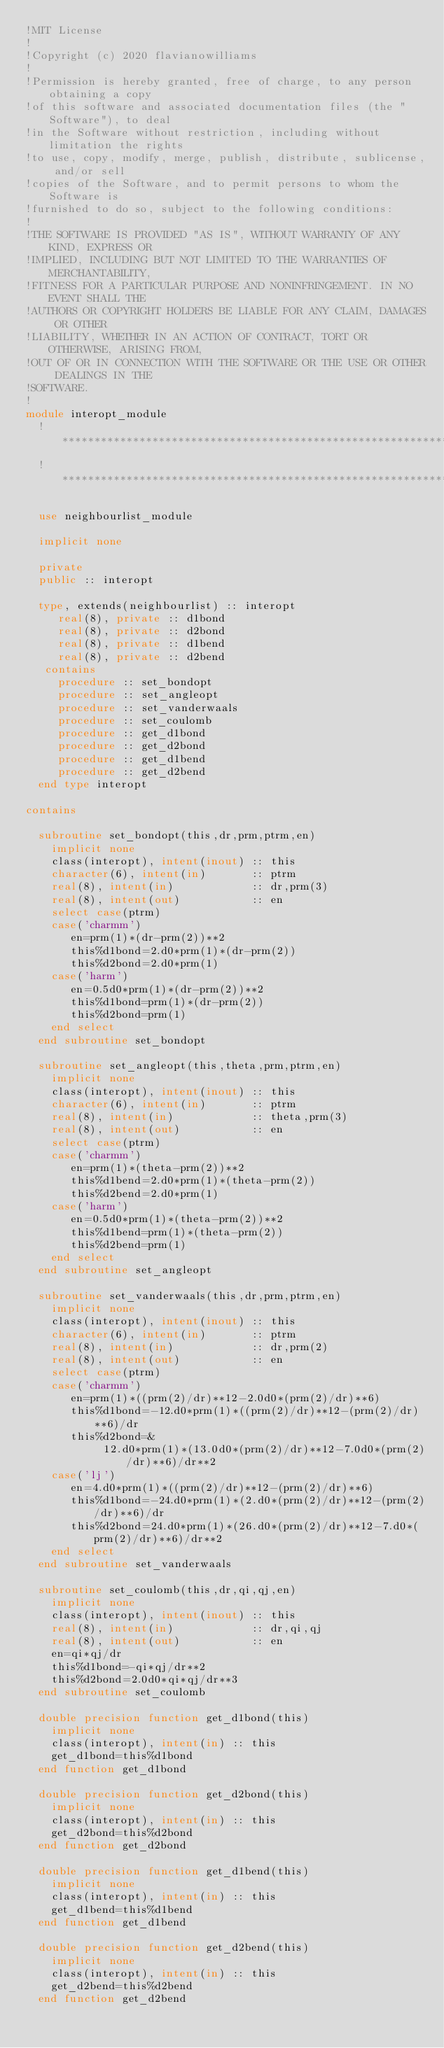<code> <loc_0><loc_0><loc_500><loc_500><_FORTRAN_>!MIT License
!
!Copyright (c) 2020 flavianowilliams
!
!Permission is hereby granted, free of charge, to any person obtaining a copy
!of this software and associated documentation files (the "Software"), to deal
!in the Software without restriction, including without limitation the rights
!to use, copy, modify, merge, publish, distribute, sublicense, and/or sell
!copies of the Software, and to permit persons to whom the Software is
!furnished to do so, subject to the following conditions:
!
!THE SOFTWARE IS PROVIDED "AS IS", WITHOUT WARRANTY OF ANY KIND, EXPRESS OR
!IMPLIED, INCLUDING BUT NOT LIMITED TO THE WARRANTIES OF MERCHANTABILITY,
!FITNESS FOR A PARTICULAR PURPOSE AND NONINFRINGEMENT. IN NO EVENT SHALL THE
!AUTHORS OR COPYRIGHT HOLDERS BE LIABLE FOR ANY CLAIM, DAMAGES OR OTHER
!LIABILITY, WHETHER IN AN ACTION OF CONTRACT, TORT OR OTHERWISE, ARISING FROM,
!OUT OF OR IN CONNECTION WITH THE SOFTWARE OR THE USE OR OTHER DEALINGS IN THE
!SOFTWARE.
!
module interopt_module
  !*******************************************************************************************
  !*******************************************************************************************

  use neighbourlist_module

  implicit none

  private
  public :: interopt

  type, extends(neighbourlist) :: interopt
     real(8), private :: d1bond
     real(8), private :: d2bond
     real(8), private :: d1bend
     real(8), private :: d2bend
   contains
     procedure :: set_bondopt
     procedure :: set_angleopt
     procedure :: set_vanderwaals
     procedure :: set_coulomb
     procedure :: get_d1bond
     procedure :: get_d2bond
     procedure :: get_d1bend
     procedure :: get_d2bend
  end type interopt

contains

  subroutine set_bondopt(this,dr,prm,ptrm,en)
    implicit none
    class(interopt), intent(inout) :: this
    character(6), intent(in)       :: ptrm
    real(8), intent(in)            :: dr,prm(3)
    real(8), intent(out)           :: en
    select case(ptrm)
    case('charmm')
       en=prm(1)*(dr-prm(2))**2
       this%d1bond=2.d0*prm(1)*(dr-prm(2))
       this%d2bond=2.d0*prm(1)
    case('harm')
       en=0.5d0*prm(1)*(dr-prm(2))**2
       this%d1bond=prm(1)*(dr-prm(2))
       this%d2bond=prm(1)
    end select
  end subroutine set_bondopt

  subroutine set_angleopt(this,theta,prm,ptrm,en)
    implicit none
    class(interopt), intent(inout) :: this
    character(6), intent(in)       :: ptrm
    real(8), intent(in)            :: theta,prm(3)
    real(8), intent(out)           :: en
    select case(ptrm)
    case('charmm')
       en=prm(1)*(theta-prm(2))**2
       this%d1bend=2.d0*prm(1)*(theta-prm(2))
       this%d2bend=2.d0*prm(1)
    case('harm')
       en=0.5d0*prm(1)*(theta-prm(2))**2
       this%d1bend=prm(1)*(theta-prm(2))
       this%d2bend=prm(1)
    end select
  end subroutine set_angleopt

  subroutine set_vanderwaals(this,dr,prm,ptrm,en)
    implicit none
    class(interopt), intent(inout) :: this
    character(6), intent(in)       :: ptrm
    real(8), intent(in)            :: dr,prm(2)
    real(8), intent(out)           :: en
    select case(ptrm)
    case('charmm')
       en=prm(1)*((prm(2)/dr)**12-2.0d0*(prm(2)/dr)**6)
       this%d1bond=-12.d0*prm(1)*((prm(2)/dr)**12-(prm(2)/dr)**6)/dr
       this%d2bond=&
            12.d0*prm(1)*(13.0d0*(prm(2)/dr)**12-7.0d0*(prm(2)/dr)**6)/dr**2
    case('lj')
       en=4.d0*prm(1)*((prm(2)/dr)**12-(prm(2)/dr)**6)
       this%d1bond=-24.d0*prm(1)*(2.d0*(prm(2)/dr)**12-(prm(2)/dr)**6)/dr
       this%d2bond=24.d0*prm(1)*(26.d0*(prm(2)/dr)**12-7.d0*(prm(2)/dr)**6)/dr**2
    end select
  end subroutine set_vanderwaals

  subroutine set_coulomb(this,dr,qi,qj,en)
    implicit none
    class(interopt), intent(inout) :: this
    real(8), intent(in)            :: dr,qi,qj
    real(8), intent(out)           :: en
    en=qi*qj/dr
    this%d1bond=-qi*qj/dr**2
    this%d2bond=2.0d0*qi*qj/dr**3
  end subroutine set_coulomb

  double precision function get_d1bond(this)
    implicit none
    class(interopt), intent(in) :: this
    get_d1bond=this%d1bond
  end function get_d1bond

  double precision function get_d2bond(this)
    implicit none
    class(interopt), intent(in) :: this
    get_d2bond=this%d2bond
  end function get_d2bond

  double precision function get_d1bend(this)
    implicit none
    class(interopt), intent(in) :: this
    get_d1bend=this%d1bend
  end function get_d1bend

  double precision function get_d2bend(this)
    implicit none
    class(interopt), intent(in) :: this
    get_d2bend=this%d2bend
  end function get_d2bend
</code> 